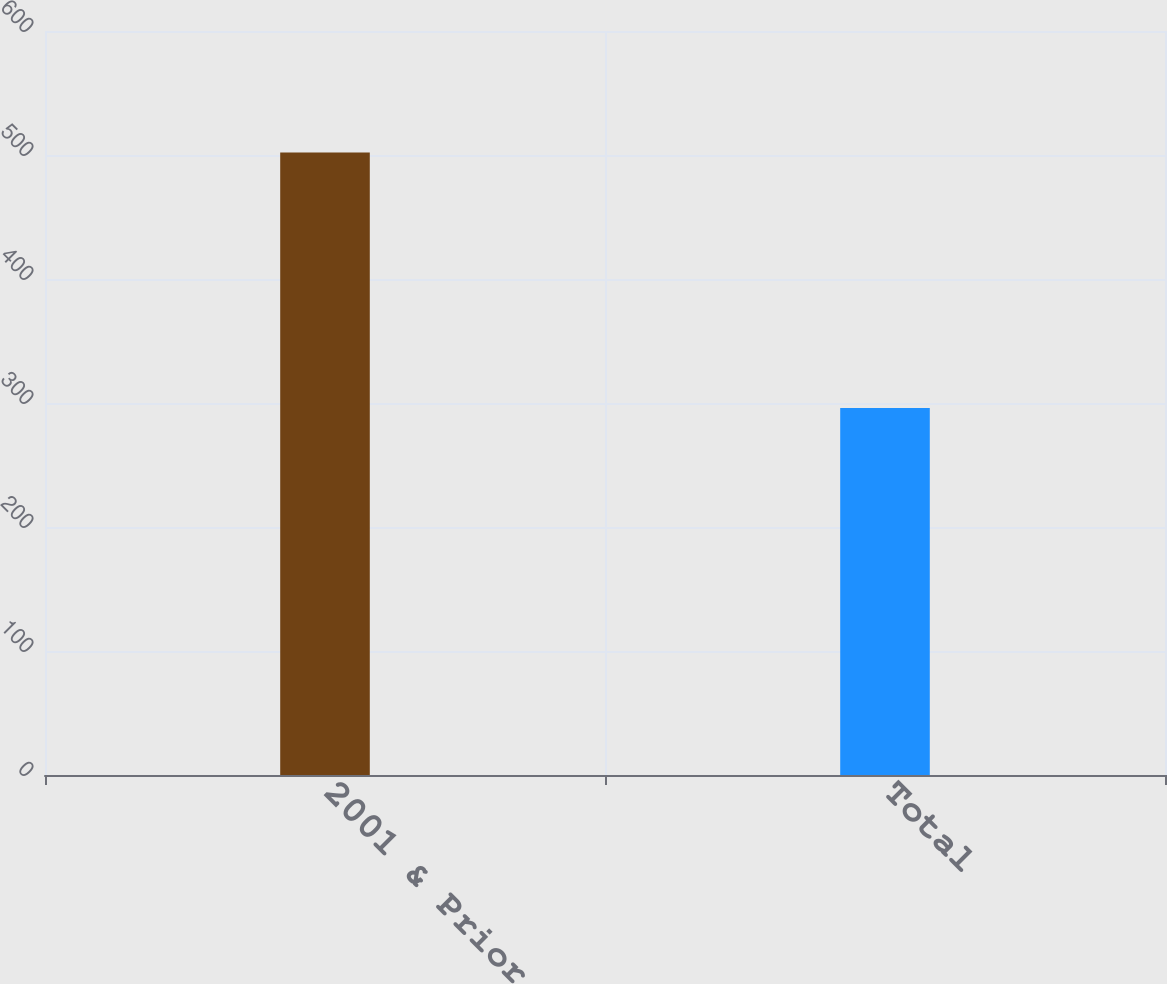<chart> <loc_0><loc_0><loc_500><loc_500><bar_chart><fcel>2001 & Prior<fcel>Total<nl><fcel>502<fcel>296<nl></chart> 